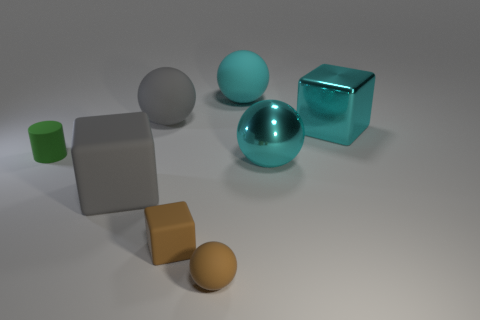There is a cyan sphere in front of the cyan rubber thing; what is its size?
Keep it short and to the point. Large. There is a gray ball; is its size the same as the metallic thing that is in front of the matte cylinder?
Your answer should be compact. Yes. There is a sphere that is in front of the metal object to the left of the metallic cube; what color is it?
Provide a succinct answer. Brown. How many other things are the same color as the cylinder?
Offer a terse response. 0. The green matte thing is what size?
Give a very brief answer. Small. Are there more tiny green matte cylinders in front of the gray sphere than things on the right side of the big gray cube?
Provide a succinct answer. No. There is a gray rubber object in front of the green thing; how many big gray rubber objects are behind it?
Make the answer very short. 1. Is the shape of the tiny brown rubber object to the left of the tiny ball the same as  the green object?
Provide a succinct answer. No. What is the material of the brown object that is the same shape as the cyan rubber thing?
Provide a short and direct response. Rubber. What number of matte cylinders are the same size as the green object?
Provide a short and direct response. 0. 